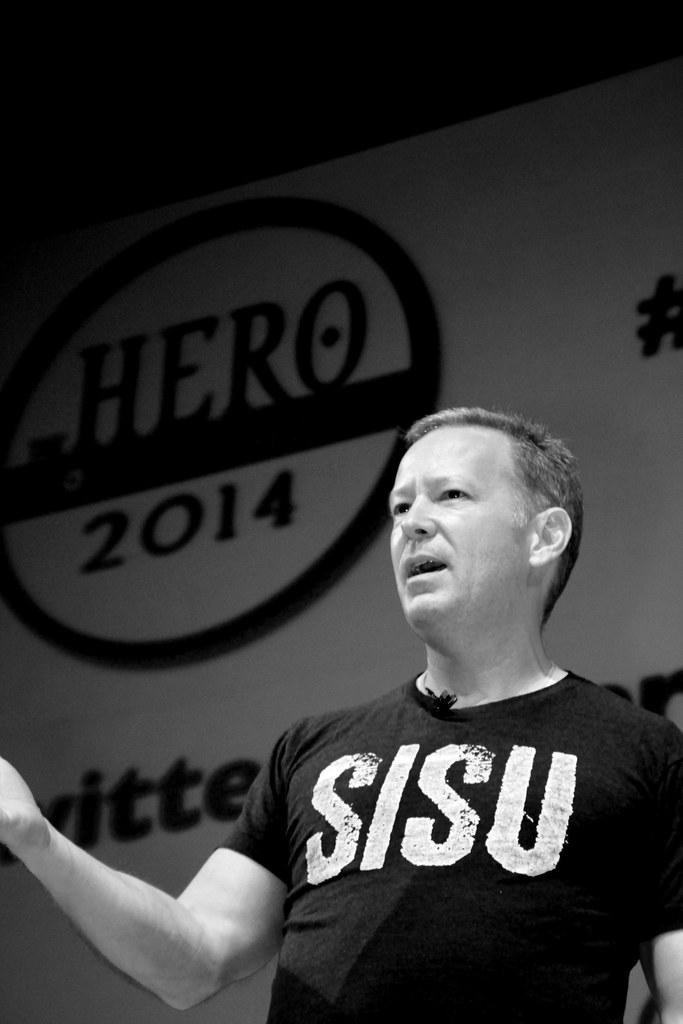<image>
Present a compact description of the photo's key features. A man wearing a tee shirt reading SISU. 